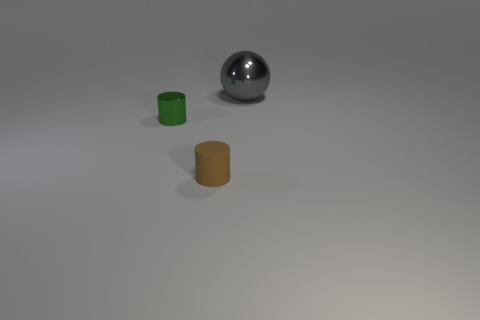Add 3 tiny shiny cylinders. How many objects exist? 6 Subtract all cylinders. How many objects are left? 1 Add 2 brown objects. How many brown objects exist? 3 Subtract 0 brown balls. How many objects are left? 3 Subtract all gray metal things. Subtract all tiny cylinders. How many objects are left? 0 Add 1 matte cylinders. How many matte cylinders are left? 2 